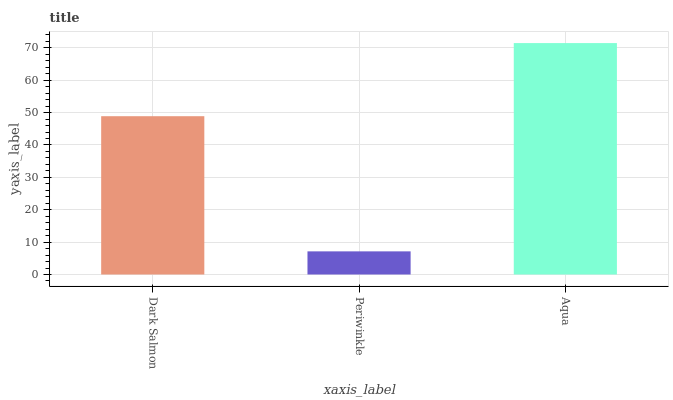Is Periwinkle the minimum?
Answer yes or no. Yes. Is Aqua the maximum?
Answer yes or no. Yes. Is Aqua the minimum?
Answer yes or no. No. Is Periwinkle the maximum?
Answer yes or no. No. Is Aqua greater than Periwinkle?
Answer yes or no. Yes. Is Periwinkle less than Aqua?
Answer yes or no. Yes. Is Periwinkle greater than Aqua?
Answer yes or no. No. Is Aqua less than Periwinkle?
Answer yes or no. No. Is Dark Salmon the high median?
Answer yes or no. Yes. Is Dark Salmon the low median?
Answer yes or no. Yes. Is Periwinkle the high median?
Answer yes or no. No. Is Aqua the low median?
Answer yes or no. No. 